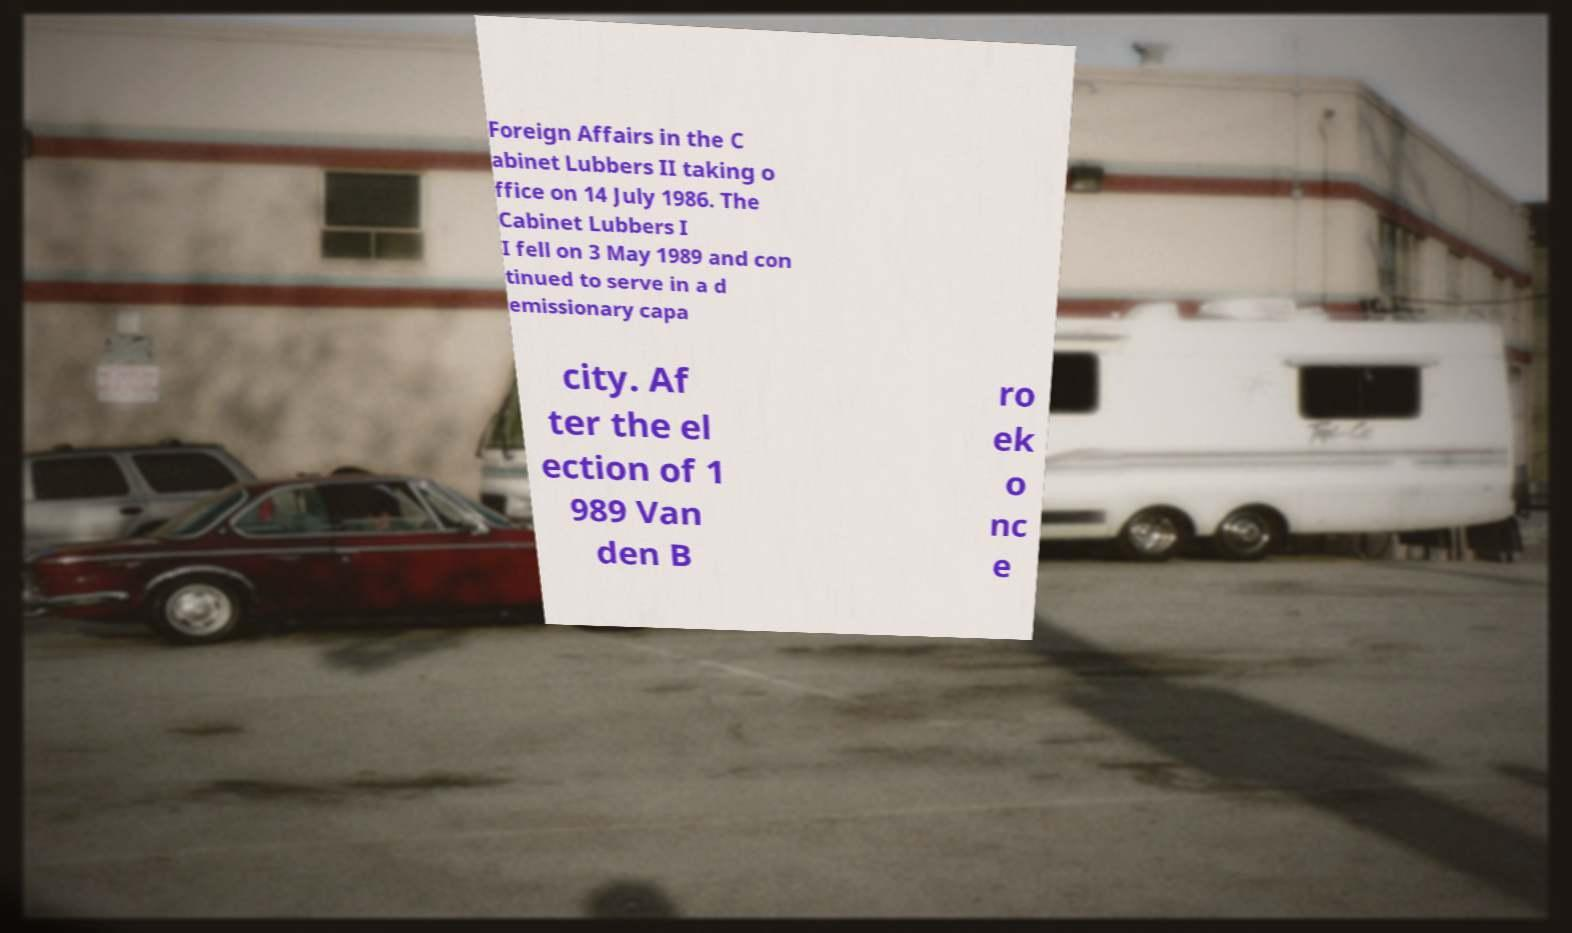Could you assist in decoding the text presented in this image and type it out clearly? Foreign Affairs in the C abinet Lubbers II taking o ffice on 14 July 1986. The Cabinet Lubbers I I fell on 3 May 1989 and con tinued to serve in a d emissionary capa city. Af ter the el ection of 1 989 Van den B ro ek o nc e 